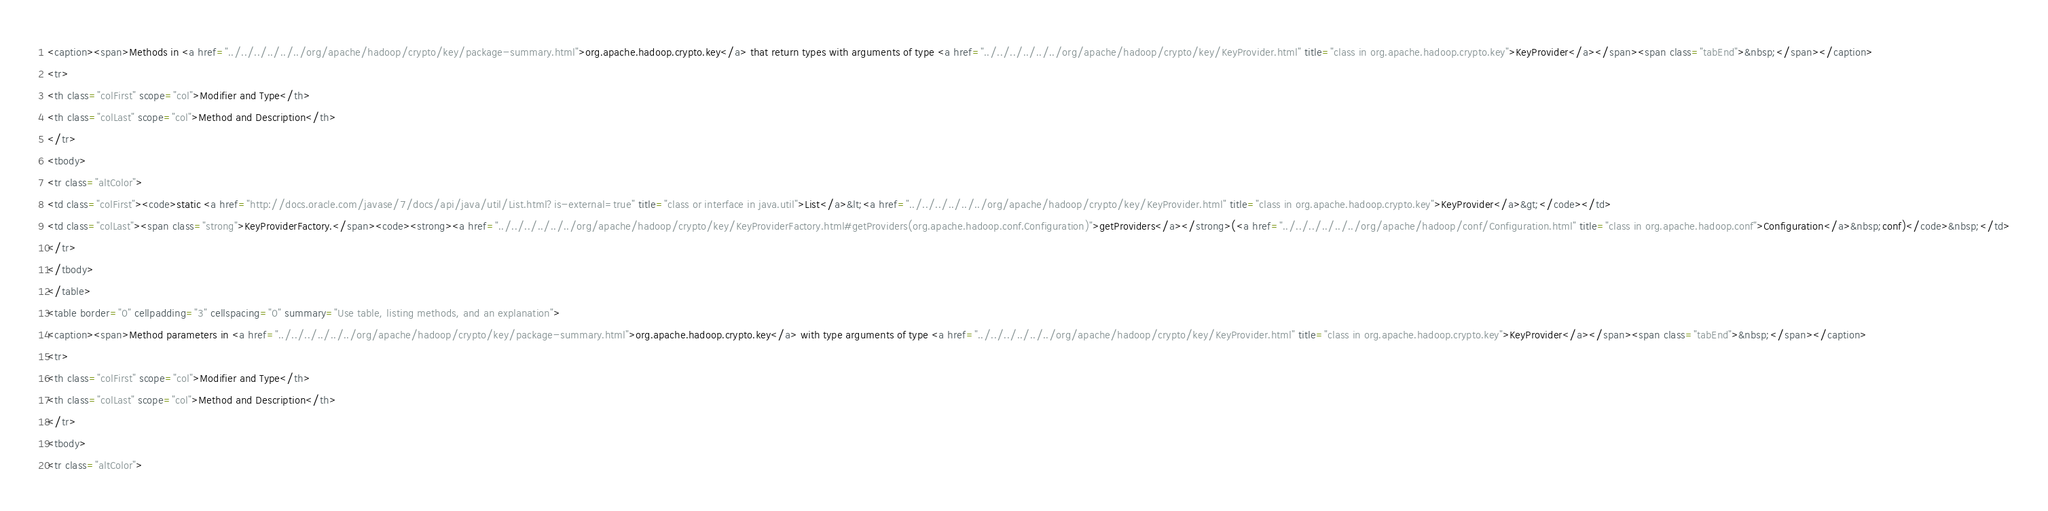<code> <loc_0><loc_0><loc_500><loc_500><_HTML_><caption><span>Methods in <a href="../../../../../../org/apache/hadoop/crypto/key/package-summary.html">org.apache.hadoop.crypto.key</a> that return types with arguments of type <a href="../../../../../../org/apache/hadoop/crypto/key/KeyProvider.html" title="class in org.apache.hadoop.crypto.key">KeyProvider</a></span><span class="tabEnd">&nbsp;</span></caption>
<tr>
<th class="colFirst" scope="col">Modifier and Type</th>
<th class="colLast" scope="col">Method and Description</th>
</tr>
<tbody>
<tr class="altColor">
<td class="colFirst"><code>static <a href="http://docs.oracle.com/javase/7/docs/api/java/util/List.html?is-external=true" title="class or interface in java.util">List</a>&lt;<a href="../../../../../../org/apache/hadoop/crypto/key/KeyProvider.html" title="class in org.apache.hadoop.crypto.key">KeyProvider</a>&gt;</code></td>
<td class="colLast"><span class="strong">KeyProviderFactory.</span><code><strong><a href="../../../../../../org/apache/hadoop/crypto/key/KeyProviderFactory.html#getProviders(org.apache.hadoop.conf.Configuration)">getProviders</a></strong>(<a href="../../../../../../org/apache/hadoop/conf/Configuration.html" title="class in org.apache.hadoop.conf">Configuration</a>&nbsp;conf)</code>&nbsp;</td>
</tr>
</tbody>
</table>
<table border="0" cellpadding="3" cellspacing="0" summary="Use table, listing methods, and an explanation">
<caption><span>Method parameters in <a href="../../../../../../org/apache/hadoop/crypto/key/package-summary.html">org.apache.hadoop.crypto.key</a> with type arguments of type <a href="../../../../../../org/apache/hadoop/crypto/key/KeyProvider.html" title="class in org.apache.hadoop.crypto.key">KeyProvider</a></span><span class="tabEnd">&nbsp;</span></caption>
<tr>
<th class="colFirst" scope="col">Modifier and Type</th>
<th class="colLast" scope="col">Method and Description</th>
</tr>
<tbody>
<tr class="altColor"></code> 